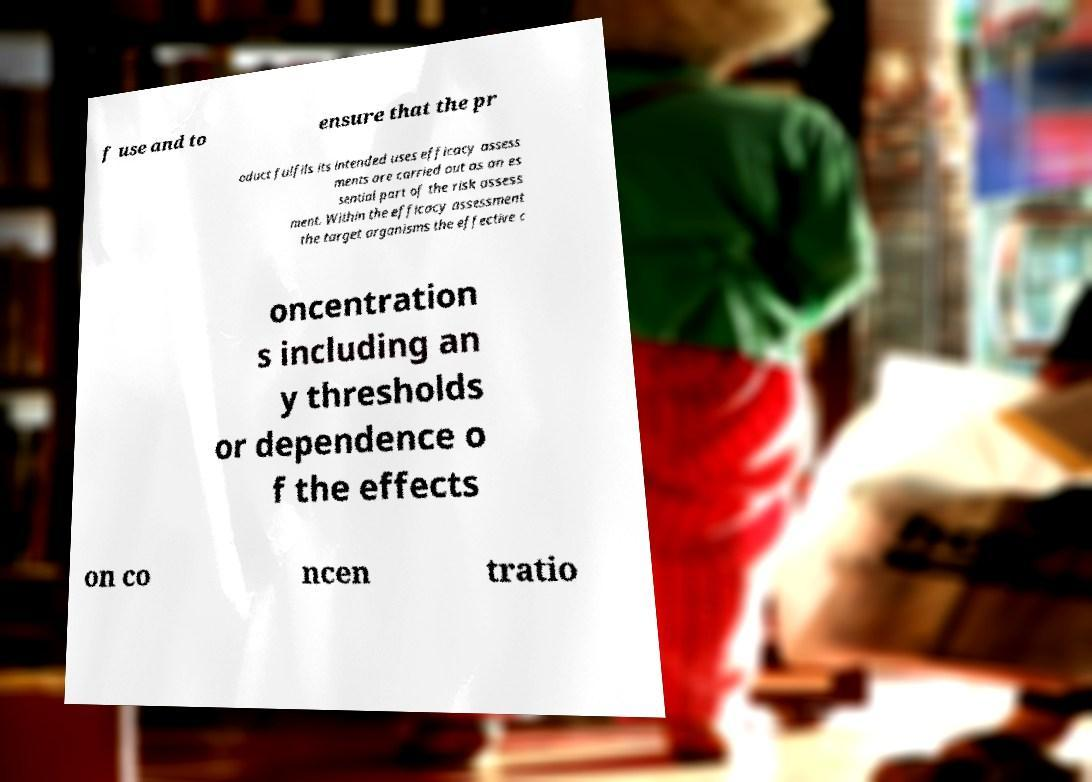Please read and relay the text visible in this image. What does it say? f use and to ensure that the pr oduct fulfils its intended uses efficacy assess ments are carried out as an es sential part of the risk assess ment. Within the efficacy assessment the target organisms the effective c oncentration s including an y thresholds or dependence o f the effects on co ncen tratio 